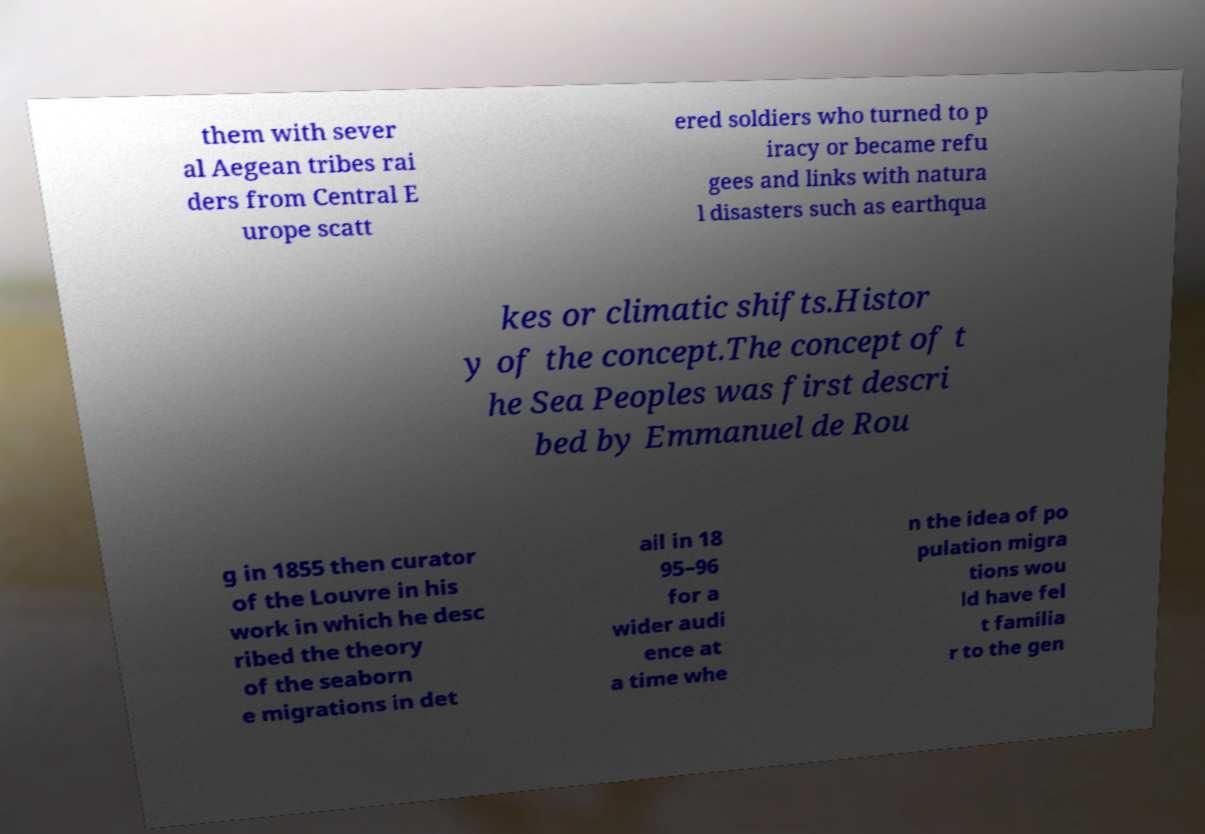Can you accurately transcribe the text from the provided image for me? them with sever al Aegean tribes rai ders from Central E urope scatt ered soldiers who turned to p iracy or became refu gees and links with natura l disasters such as earthqua kes or climatic shifts.Histor y of the concept.The concept of t he Sea Peoples was first descri bed by Emmanuel de Rou g in 1855 then curator of the Louvre in his work in which he desc ribed the theory of the seaborn e migrations in det ail in 18 95–96 for a wider audi ence at a time whe n the idea of po pulation migra tions wou ld have fel t familia r to the gen 